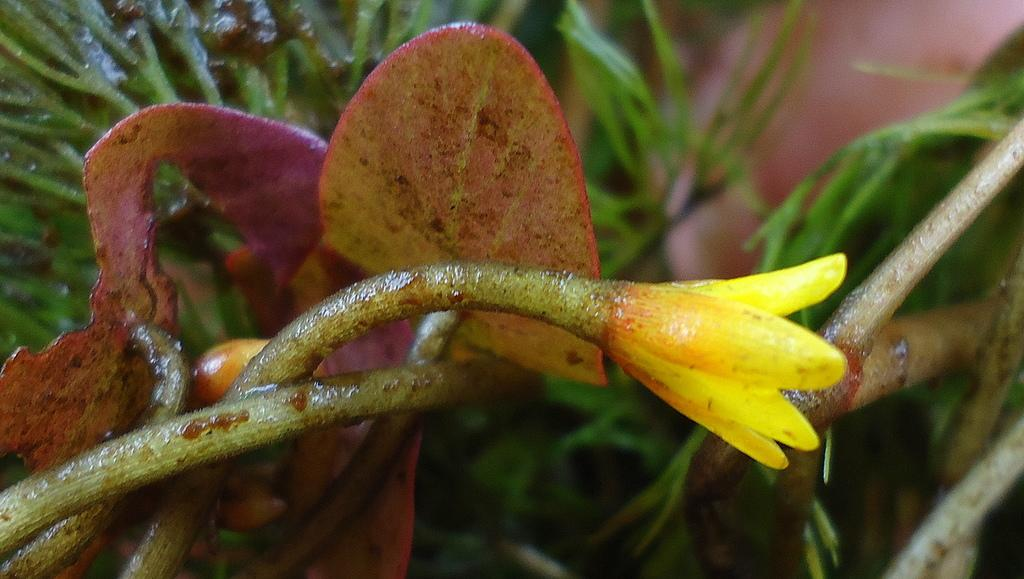What type of flower is in the image? There is a yellow flower in the image. Can you describe the flower's structure? The flower has a stem. What else can be seen in the image besides the flower? There is a tree in the image. What type of sweater is the flower wearing in the image? There is no sweater present in the image, as flowers do not wear clothing. Can you describe the star that is shining above the flower in the image? There is no star present in the image; only the yellow flower and the tree are visible. 